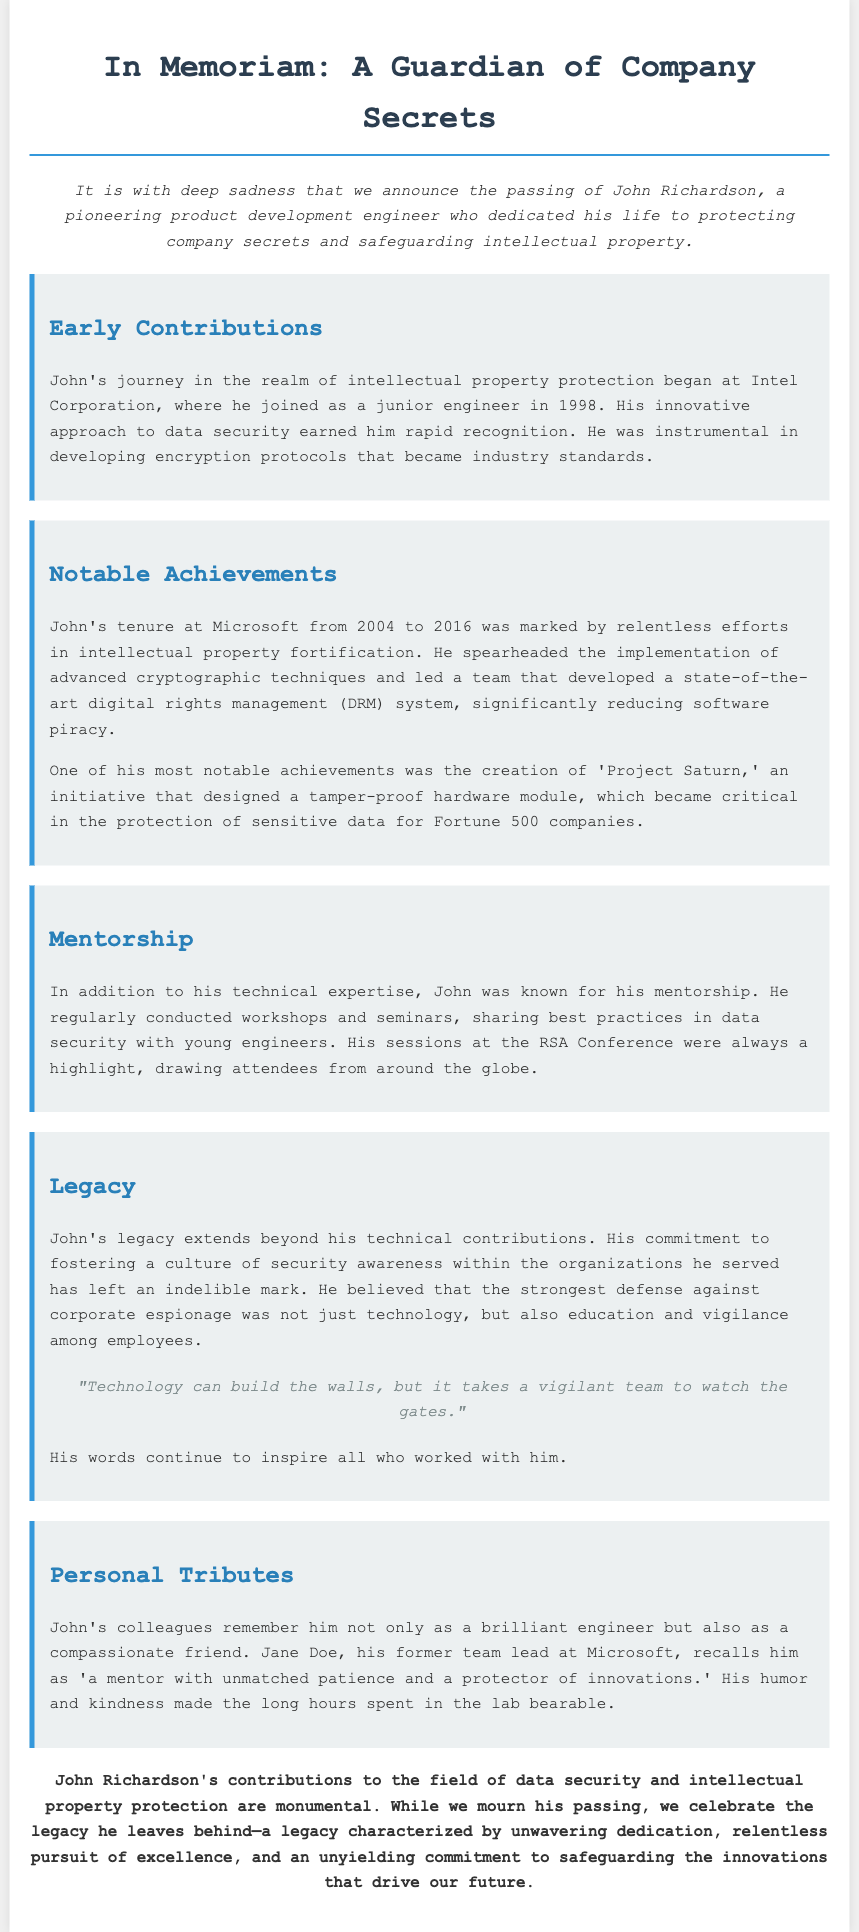What was John Richardson's role? John Richardson was a pioneering product development engineer dedicated to protecting company secrets.
Answer: product development engineer In which year did John start his journey at Intel Corporation? John started at Intel Corporation in 1998.
Answer: 1998 What notable project did John create that protected sensitive data? John created 'Project Saturn,' which designed a tamper-proof hardware module.
Answer: Project Saturn Which company did John work for from 2004 to 2016? John worked for Microsoft from 2004 to 2016.
Answer: Microsoft What was one key achievement in John's career at Microsoft? He developed a state-of-the-art digital rights management (DRM) system.
Answer: digital rights management (DRM) system What educational activity did John engage in for young engineers? John regularly conducted workshops and seminars sharing best practices in data security.
Answer: workshops and seminars What did John believe was important in defending against corporate espionage? John believed that security awareness among employees was crucial.
Answer: education and vigilance Who described John as a mentor with unmatched patience? Jane Doe, his former team lead at Microsoft, described him this way.
Answer: Jane Doe What was the quote attributed to John regarding technology and vigilance? "Technology can build the walls, but it takes a vigilant team to watch the gates."
Answer: "Technology can build the walls, but it takes a vigilant team to watch the gates." 